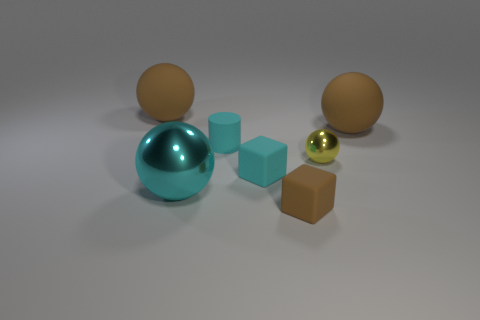What materials do the objects in the image appear to be made of? The objects in the image appear to be rendered with different materials. The two cubes and the tiny block seem to have a matte finish, possibly representing a plastic or painted wood material. The teal and brown balls have a smooth, shiny texture that could suggest a polished metal or ceramic, and the small yellow ball seems to possess a reflective material, indicatively a polished metal or glass. 